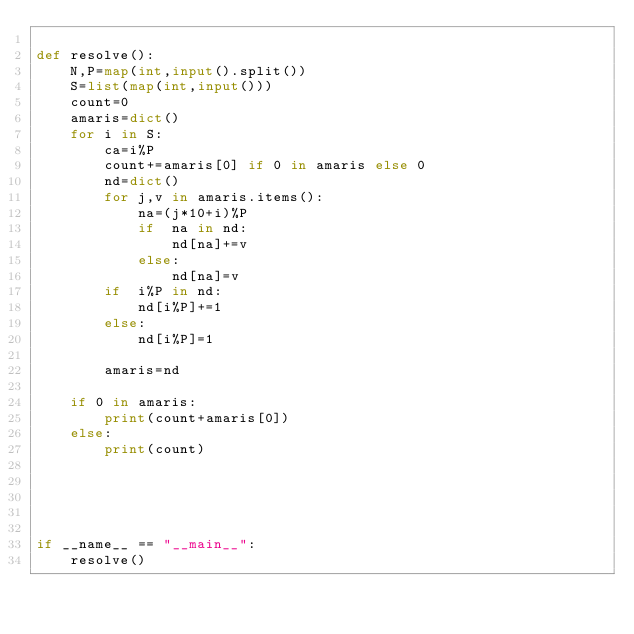<code> <loc_0><loc_0><loc_500><loc_500><_Python_>
def resolve():
    N,P=map(int,input().split())
    S=list(map(int,input()))
    count=0
    amaris=dict()
    for i in S:
        ca=i%P
        count+=amaris[0] if 0 in amaris else 0
        nd=dict()
        for j,v in amaris.items():
            na=(j*10+i)%P
            if  na in nd:
                nd[na]+=v
            else:
                nd[na]=v
        if  i%P in nd:
            nd[i%P]+=1
        else:
            nd[i%P]=1
        
        amaris=nd
    
    if 0 in amaris:
        print(count+amaris[0])
    else:
        print(count)


                


if __name__ == "__main__":
    resolve()</code> 